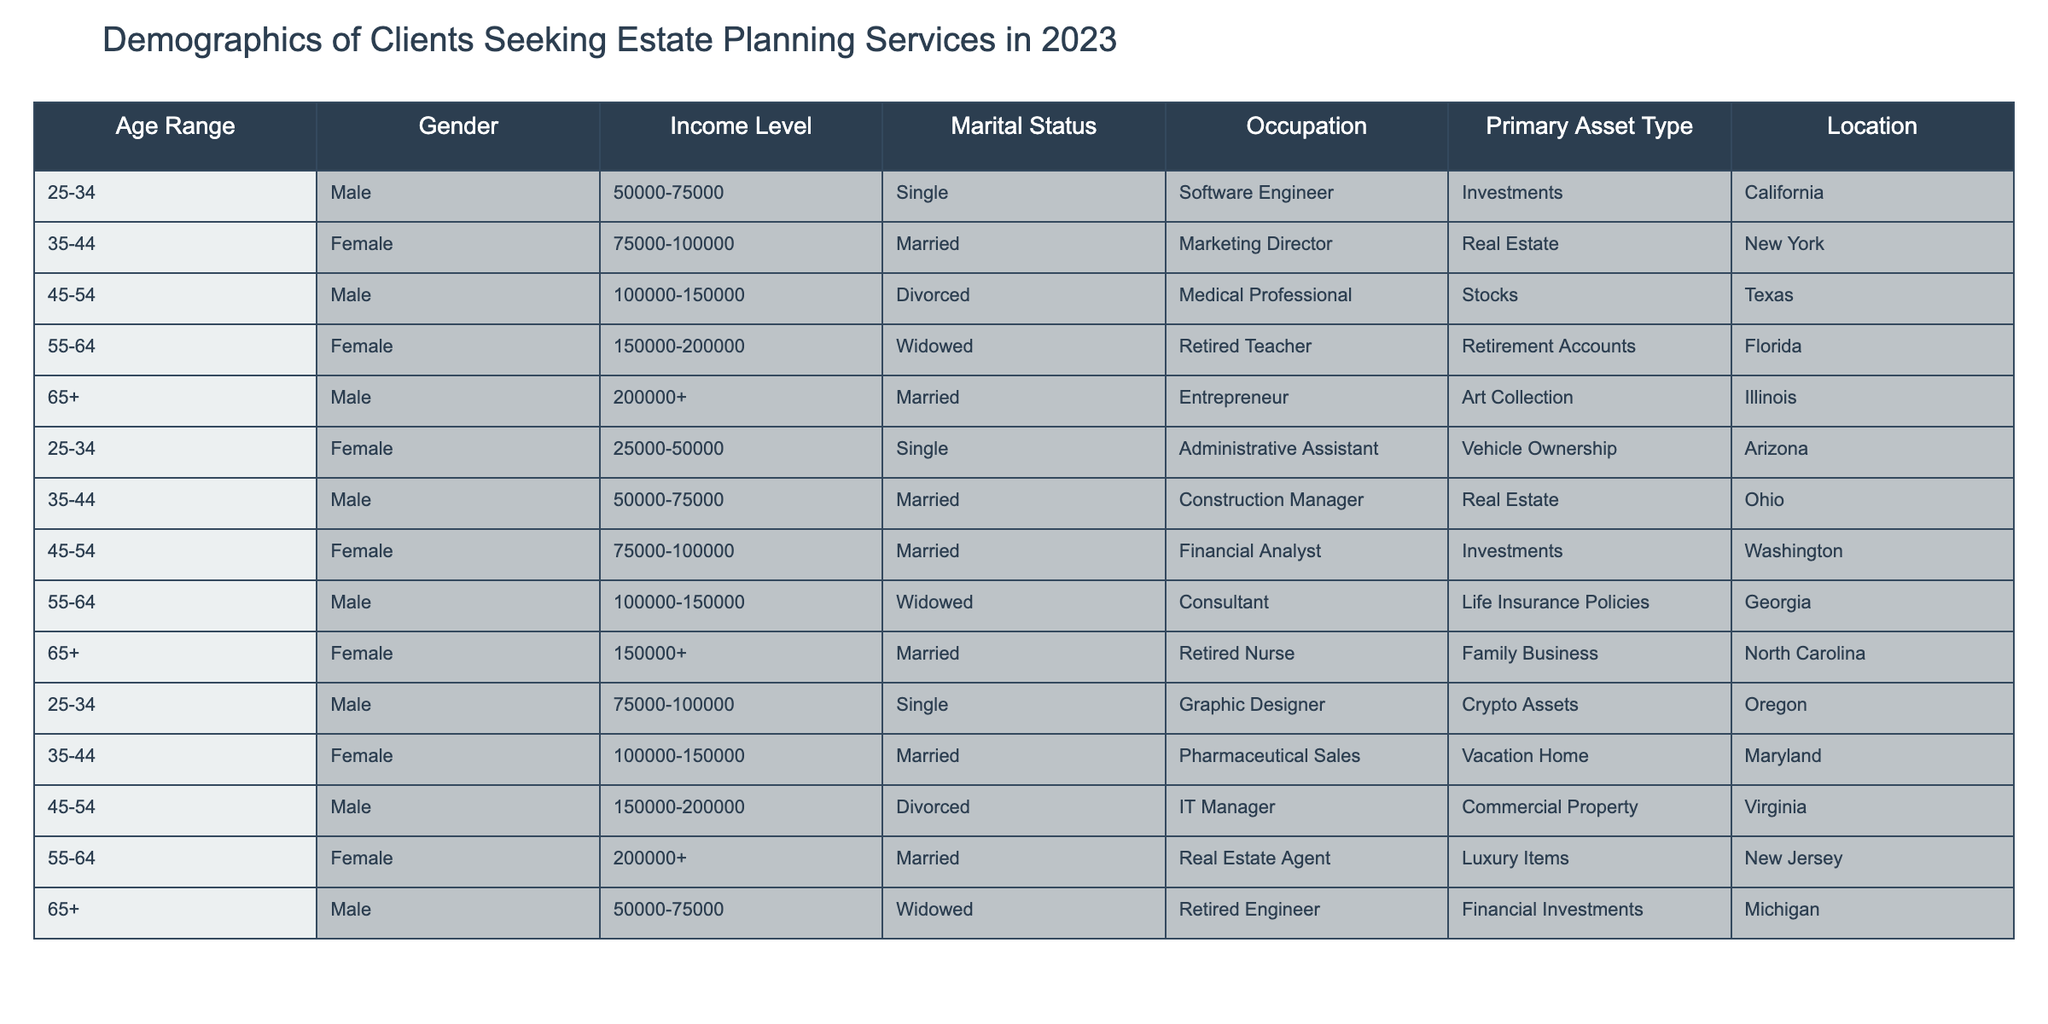What age range has the highest representation in clients seeking estate planning services? By examining the table, we can count the frequency of each age range listed. The age ranges are 25-34, 35-44, 45-54, 55-64, and 65+. Each age range has at least one entry, but the age range 35-44 appears in five entries, which is the highest compared to others.
Answer: 35-44 What is the primary asset type for clients aged 55-64? In the table, we can filter the entries to those specifically in the 55-64 age range. These clients have the primary asset types as "Retirement Accounts," "Life Insurance Policies," and "Luxury Items." Therefore, there are multiple asset types for this age range.
Answer: Retirement Accounts, Life Insurance Policies, Luxury Items Are there more male clients or female clients seeking estate planning services? To determine this, we can count the number of entries for each gender. There are six male clients and six female clients listed in the table, making the counts equal.
Answer: Equal What is the income level of the youngest male client seeking estate planning services? The youngest male client can be identified by looking for the entry under the age range 25-34. Within this range, we have two male clients: one has an income of 50,000-75,000, and the other has 75,000-100,000. The lowest income is 50,000-75,000.
Answer: 50,000-75,000 What percentage of clients are single? To calculate the percentage of single clients, we count the total number of clients (12) and then the number of clients who are single (3). The percentage is calculated as (3/12) * 100 = 25%.
Answer: 25% Is it true that all clients aged 65 and over are married? By inspecting the entries for clients aged 65 and above, we find that there are three clients listed: two are married and one is widowed. Therefore, the statement is false.
Answer: False What type of occupation is most commonly associated with clients having a primary asset type of "Real Estate"? We can filter the table for those clients whose primary asset type is "Real Estate." In this case, there are three clients with this primary asset type, and their occupations are listed as "Marketing Director" and "Construction Manager." Thus, the common occupations linked to "Real Estate" are these two.
Answer: Marketing Director and Construction Manager What is the average income level of clients who are divorced? We first filter the entries for clients with a marital status of "Divorced." There are two entries with income levels of 100,000-150,000 and 150,000-200,000. To find the average, we must represent these as numerical values: (125000 + 175000) / 2 = 150000.
Answer: 150000 Which location has clients with the highest income level listed? We can scan through the table for income levels and their corresponding locations. The highest income level is marked as 200000+, which appears under "Illinois."
Answer: Illinois How many clients have a primary asset type categorized as "Investments"? We locate the clients with the primary asset type of "Investments." According to the table, there are four clients with this type, located in California, Washington, and Texas.
Answer: 4 